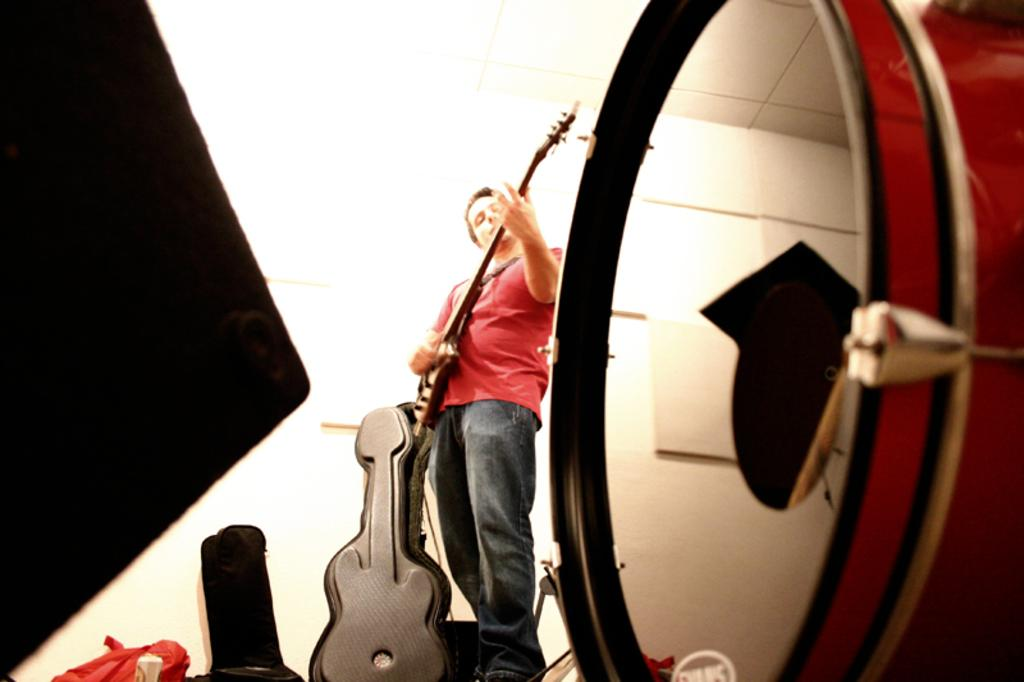What musical instrument is present in the image? There is a drum in the image. Can you describe the person in the image? There is a person standing in the image. What is the person holding in the image? The person is holding a guitar. What type of cloth is draped over the drum in the image? There is no cloth draped over the drum in the image; only the drum and the person holding a guitar are present. What story is the person telling while holding the guitar in the image? There is no story being told in the image; the person is simply holding a guitar. 